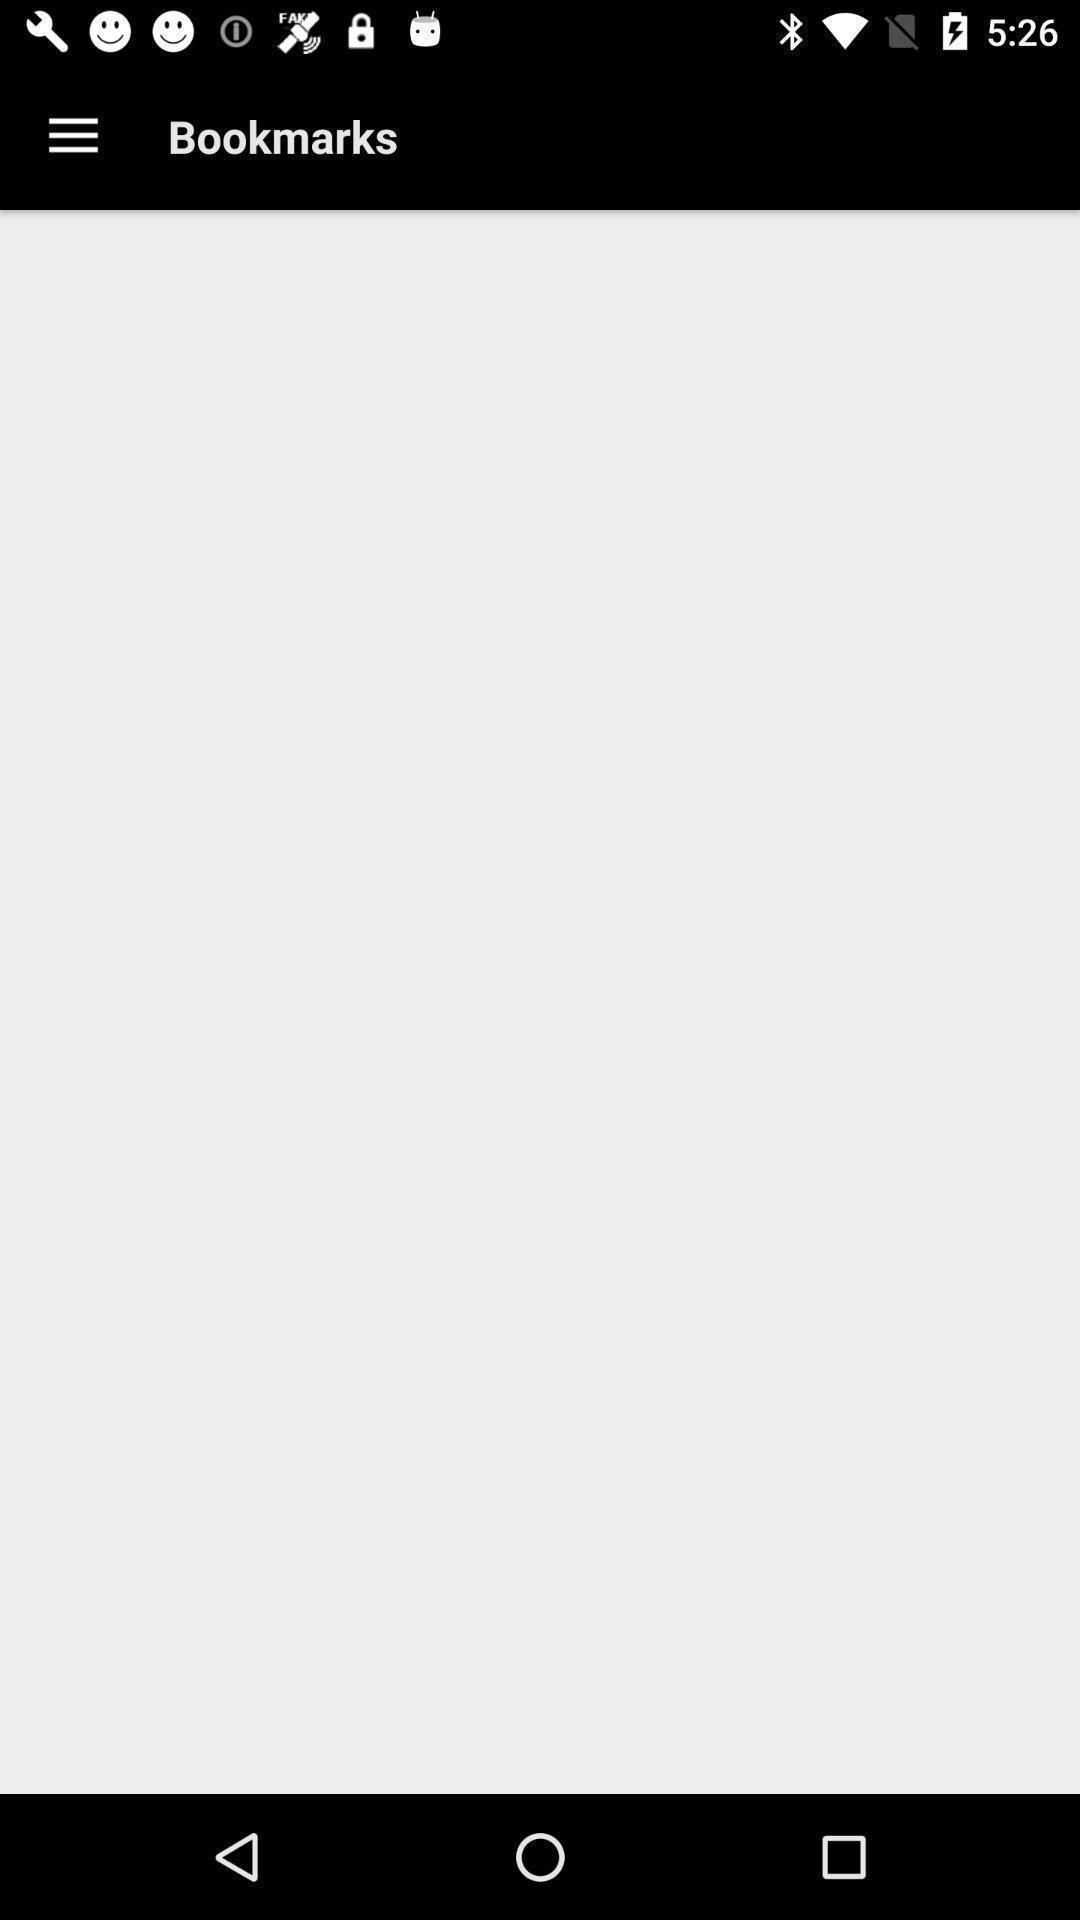Provide a description of this screenshot. Showing information in the bookmarks. 